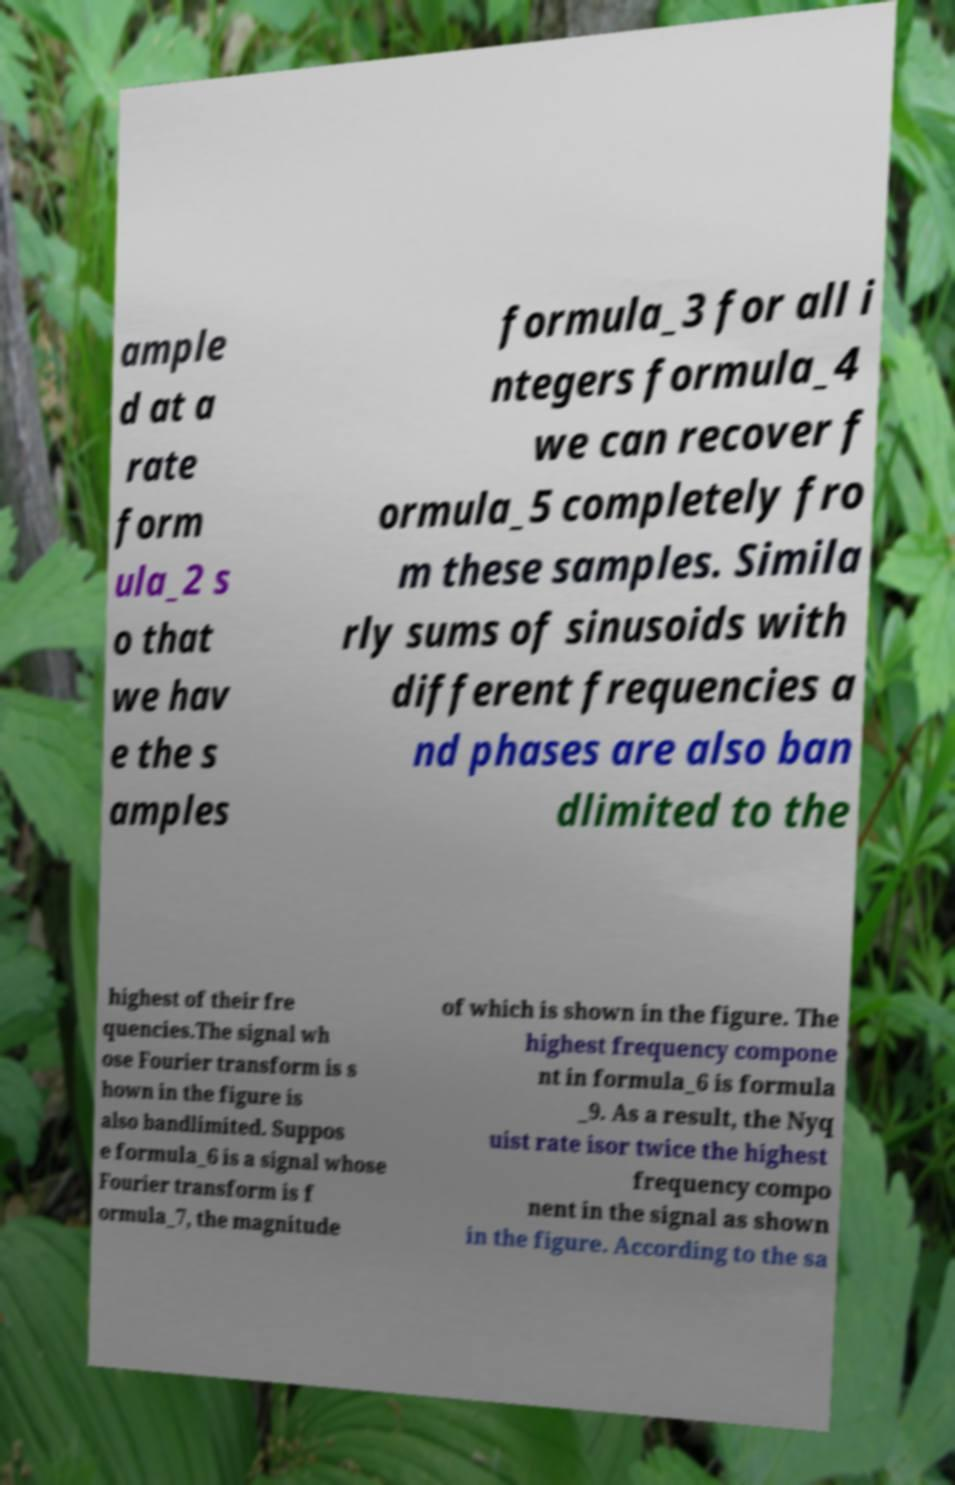Can you accurately transcribe the text from the provided image for me? ample d at a rate form ula_2 s o that we hav e the s amples formula_3 for all i ntegers formula_4 we can recover f ormula_5 completely fro m these samples. Simila rly sums of sinusoids with different frequencies a nd phases are also ban dlimited to the highest of their fre quencies.The signal wh ose Fourier transform is s hown in the figure is also bandlimited. Suppos e formula_6 is a signal whose Fourier transform is f ormula_7, the magnitude of which is shown in the figure. The highest frequency compone nt in formula_6 is formula _9. As a result, the Nyq uist rate isor twice the highest frequency compo nent in the signal as shown in the figure. According to the sa 